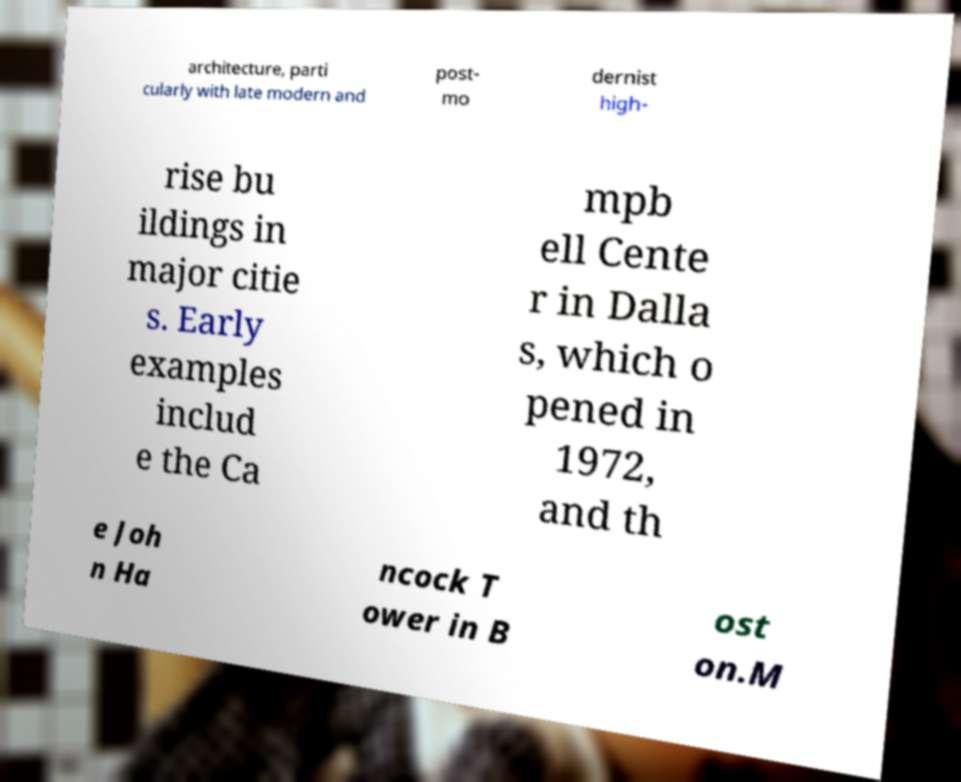Can you accurately transcribe the text from the provided image for me? architecture, parti cularly with late modern and post- mo dernist high- rise bu ildings in major citie s. Early examples includ e the Ca mpb ell Cente r in Dalla s, which o pened in 1972, and th e Joh n Ha ncock T ower in B ost on.M 